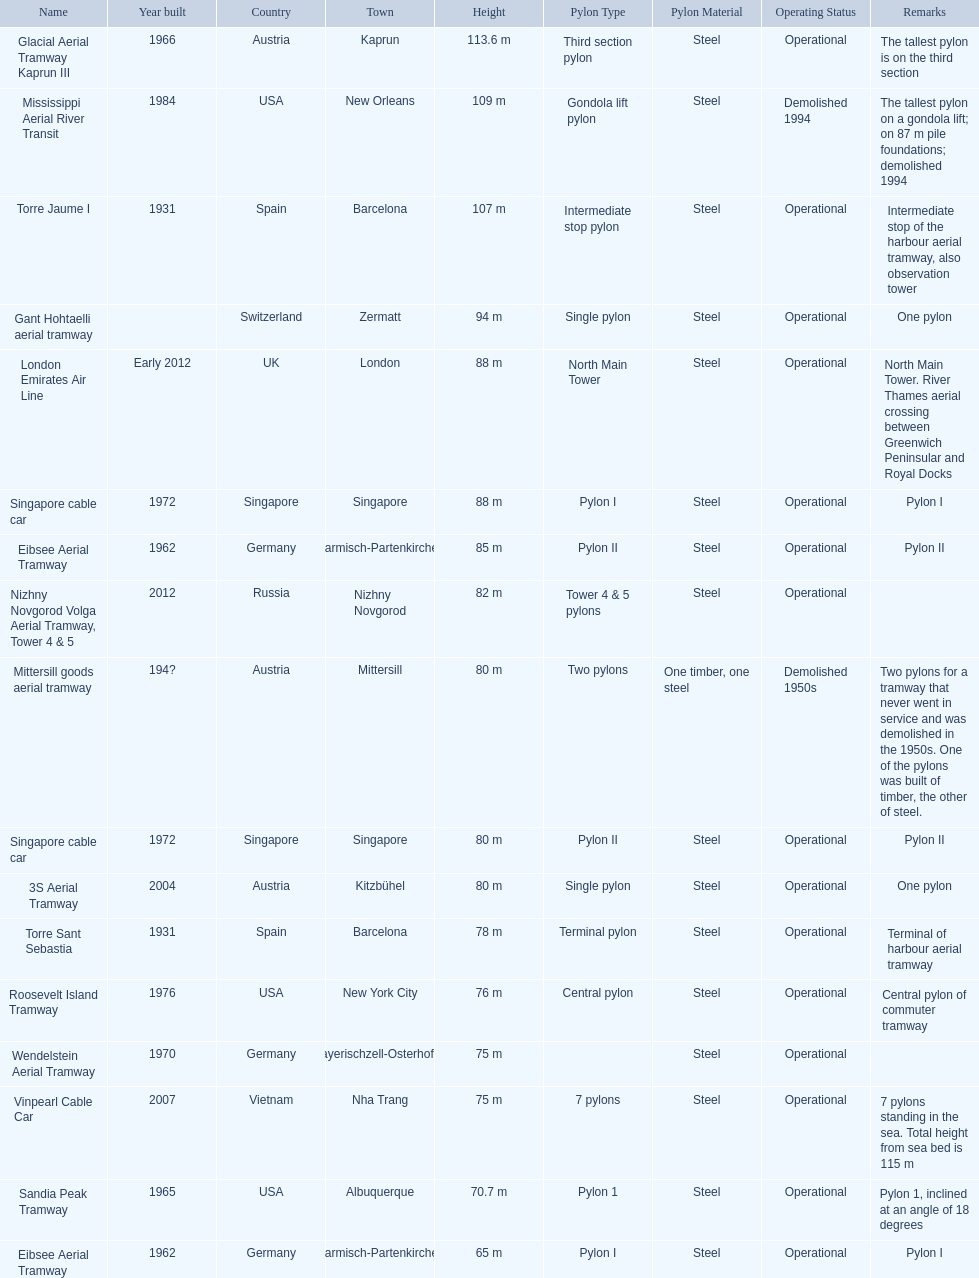Which aerial lifts are over 100 meters tall? Glacial Aerial Tramway Kaprun III, Mississippi Aerial River Transit, Torre Jaume I. Which of those was built last? Mississippi Aerial River Transit. And what is its total height? 109 m. 